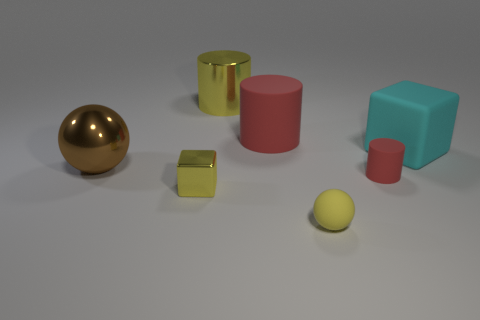What shape is the cyan rubber object that is the same size as the brown sphere?
Your answer should be very brief. Cube. There is a large rubber block; how many big objects are in front of it?
Provide a succinct answer. 1. What number of objects are yellow objects or large blue shiny cylinders?
Provide a short and direct response. 3. What is the shape of the yellow thing that is behind the small rubber ball and in front of the big shiny cylinder?
Give a very brief answer. Cube. How many brown objects are there?
Your response must be concise. 1. What is the color of the tiny ball that is the same material as the small cylinder?
Your response must be concise. Yellow. Is the number of big yellow shiny objects greater than the number of blue cylinders?
Provide a succinct answer. Yes. There is a metal object that is in front of the cyan rubber thing and right of the brown thing; what size is it?
Your answer should be very brief. Small. What is the material of the ball that is the same color as the tiny metallic block?
Provide a short and direct response. Rubber. Is the number of small matte things left of the tiny yellow sphere the same as the number of purple blocks?
Offer a very short reply. Yes. 